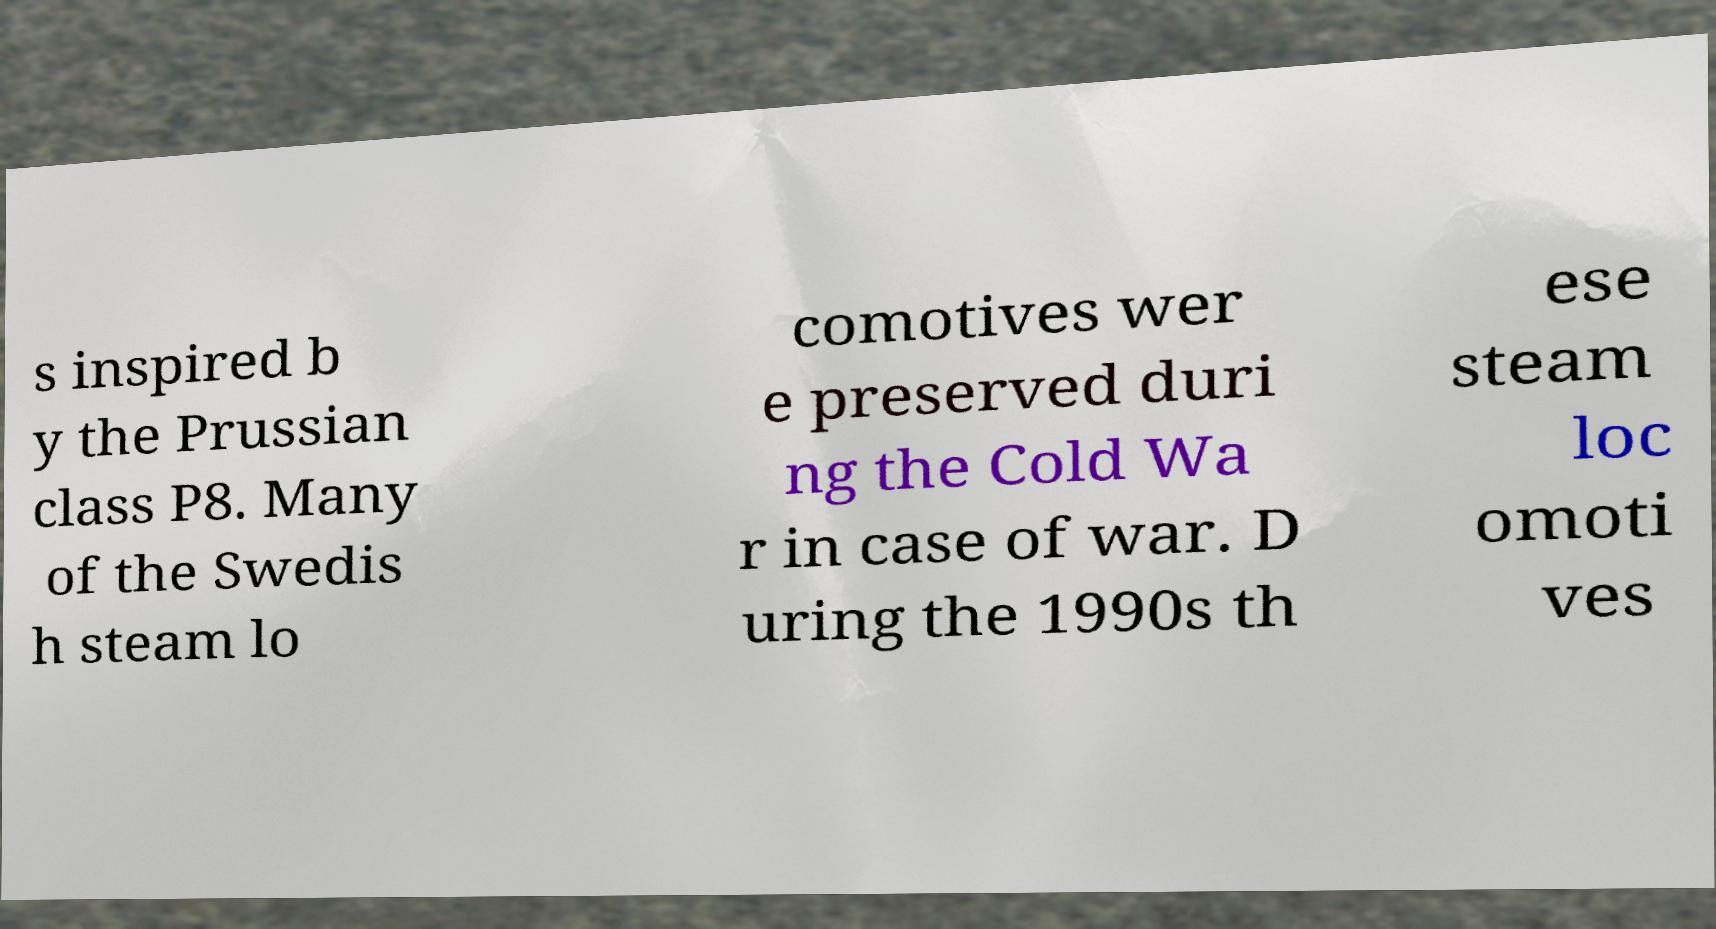There's text embedded in this image that I need extracted. Can you transcribe it verbatim? s inspired b y the Prussian class P8. Many of the Swedis h steam lo comotives wer e preserved duri ng the Cold Wa r in case of war. D uring the 1990s th ese steam loc omoti ves 